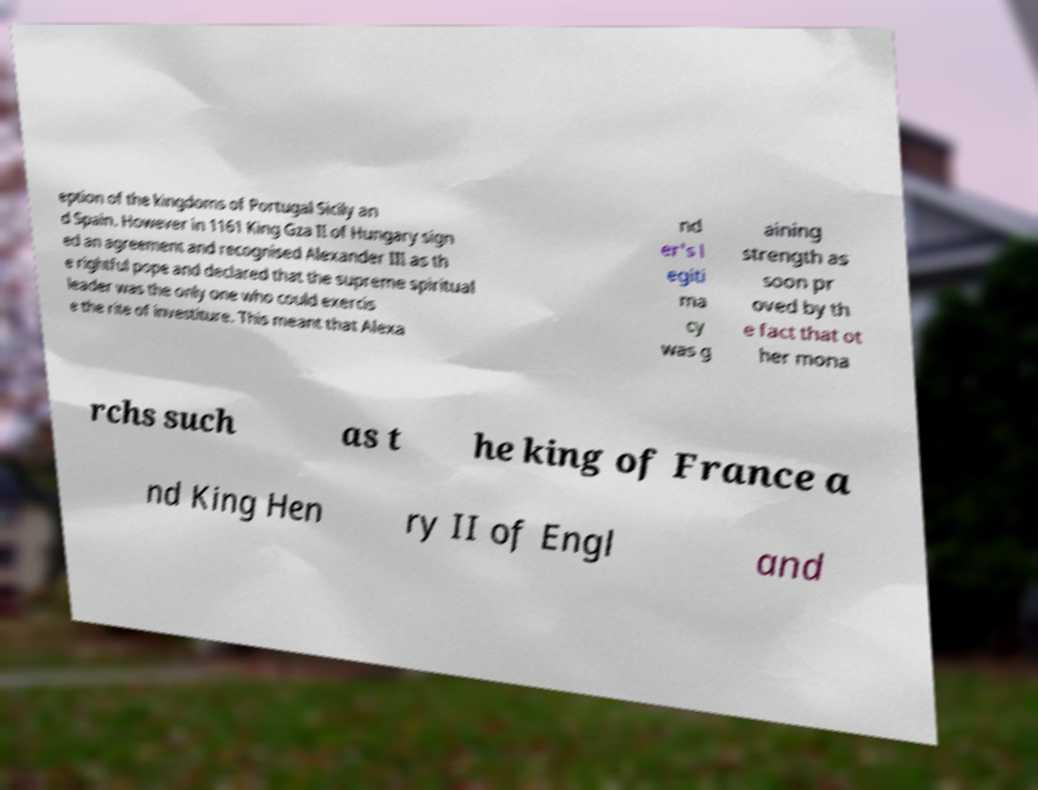Can you accurately transcribe the text from the provided image for me? eption of the kingdoms of Portugal Sicily an d Spain. However in 1161 King Gza II of Hungary sign ed an agreement and recognised Alexander III as th e rightful pope and declared that the supreme spiritual leader was the only one who could exercis e the rite of investiture. This meant that Alexa nd er's l egiti ma cy was g aining strength as soon pr oved by th e fact that ot her mona rchs such as t he king of France a nd King Hen ry II of Engl and 